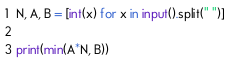<code> <loc_0><loc_0><loc_500><loc_500><_Python_>N, A, B = [int(x) for x in input().split(" ")]

print(min(A*N, B))</code> 